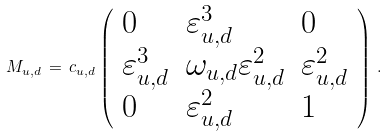Convert formula to latex. <formula><loc_0><loc_0><loc_500><loc_500>M _ { u , d } \, = \, c _ { u , d } \left ( \begin{array} { l l l } { 0 } & { { \varepsilon _ { u , d } ^ { 3 } } } & { 0 } \\ { { \varepsilon _ { u , d } ^ { 3 } } } & { { \omega _ { u , d } \varepsilon _ { u , d } ^ { 2 } } } & { { \varepsilon _ { u , d } ^ { 2 } } } \\ { 0 } & { { \varepsilon _ { u , d } ^ { 2 } } } & { 1 } \end{array} \right ) \, .</formula> 